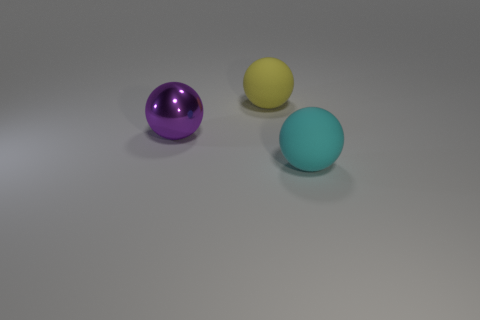How many objects are either large spheres that are on the left side of the yellow matte object or objects that are right of the big shiny object?
Offer a very short reply. 3. What number of objects are matte objects or purple metallic objects?
Your answer should be very brief. 3. There is a sphere that is in front of the yellow thing and right of the big shiny object; what is its size?
Keep it short and to the point. Large. What number of purple objects have the same material as the large yellow object?
Give a very brief answer. 0. There is another big sphere that is the same material as the yellow sphere; what is its color?
Your response must be concise. Cyan. There is a matte ball in front of the big metal ball; is its color the same as the metallic ball?
Keep it short and to the point. No. What is the material of the large sphere in front of the metal sphere?
Your answer should be compact. Rubber. Are there the same number of big rubber things that are in front of the cyan object and red things?
Give a very brief answer. Yes. What is the color of the other shiny thing that is the same shape as the big yellow thing?
Your answer should be very brief. Purple. Is the cyan ball the same size as the yellow sphere?
Offer a very short reply. Yes. 